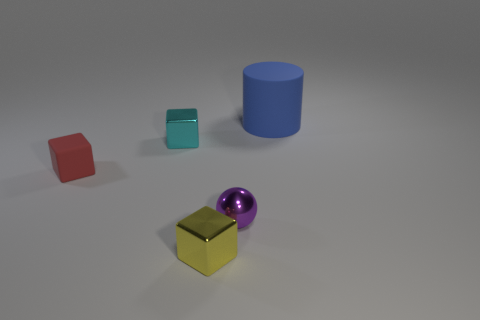Subtract all metallic cubes. How many cubes are left? 1 Add 3 purple shiny objects. How many objects exist? 8 Subtract all blocks. How many objects are left? 2 Subtract all tiny yellow metallic objects. Subtract all small red matte blocks. How many objects are left? 3 Add 4 small balls. How many small balls are left? 5 Add 2 balls. How many balls exist? 3 Subtract 0 blue cubes. How many objects are left? 5 